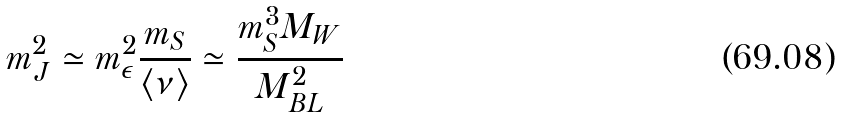Convert formula to latex. <formula><loc_0><loc_0><loc_500><loc_500>m _ { J } ^ { 2 } \simeq m _ { \epsilon } ^ { 2 } { \frac { m _ { S } } { \langle \nu \rangle } } \simeq { \frac { m _ { S } ^ { 3 } M _ { W } } { M _ { B L } ^ { 2 } } }</formula> 